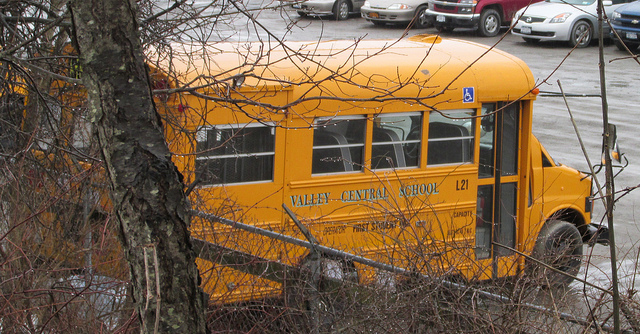Please extract the text content from this image. VALLEY CENTRAL SCHOOL L21 MAST 